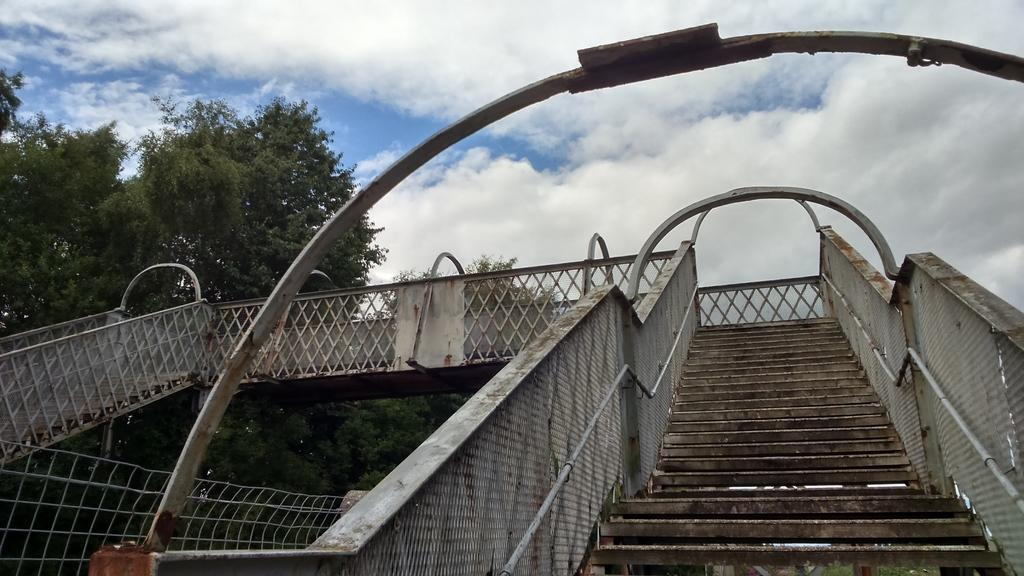What type of structure is in the image? There is a foot over bridge in the image. What features does the foot over bridge have? The foot over bridge has railing and steps. What can be seen in the background of the image? Trees and the sky are visible in the background of the image. What is the condition of the sky in the image? Clouds are present in the sky. Can you tell me how many members of the band are visible on the foot over bridge? There is no band present on the foot over bridge in the image. What color is the tongue of the person standing on the foot over bridge? There is no person or tongue visible on the foot over bridge in the image. 